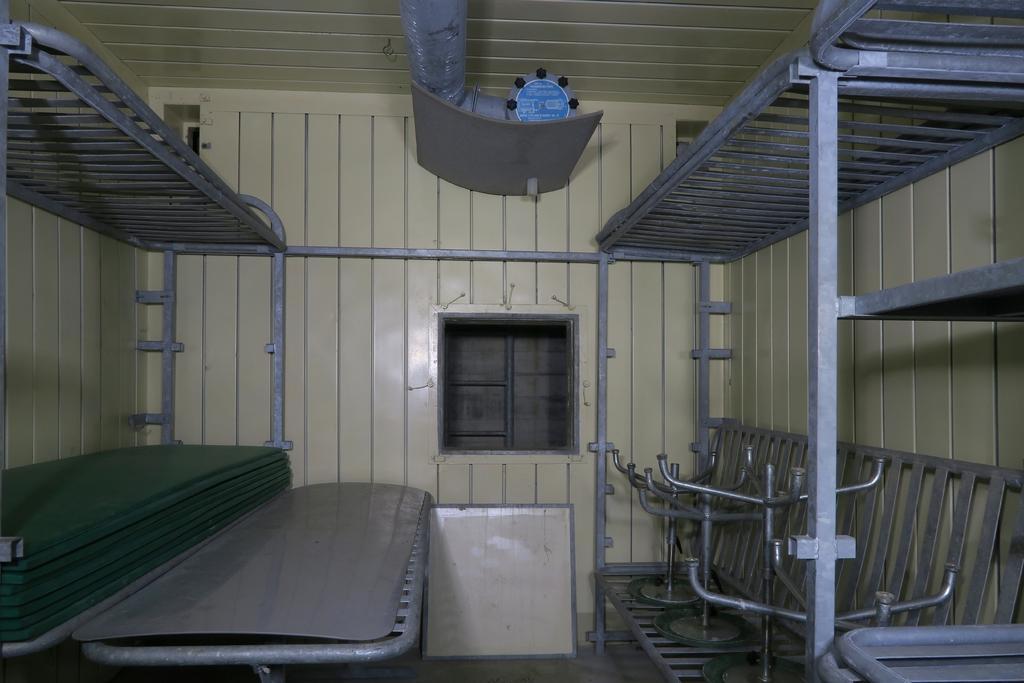Please provide a concise description of this image. In the picture we can see the attached berths. 